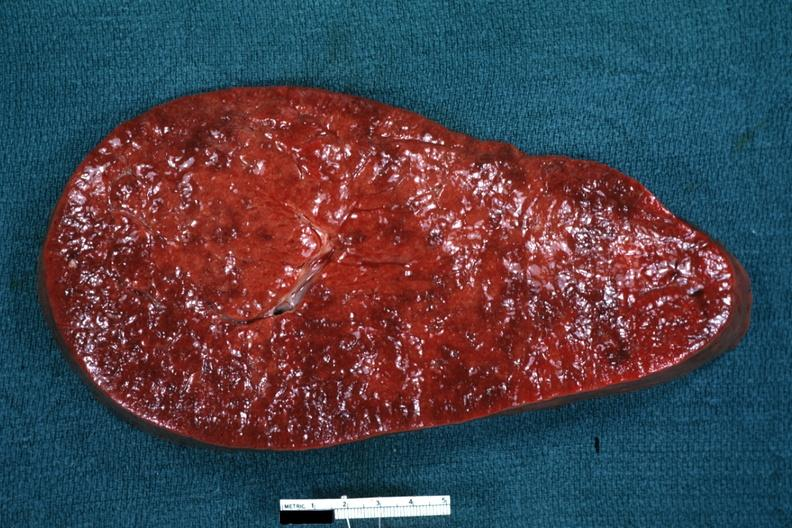s myelomonocytic leukemia present?
Answer the question using a single word or phrase. Yes 